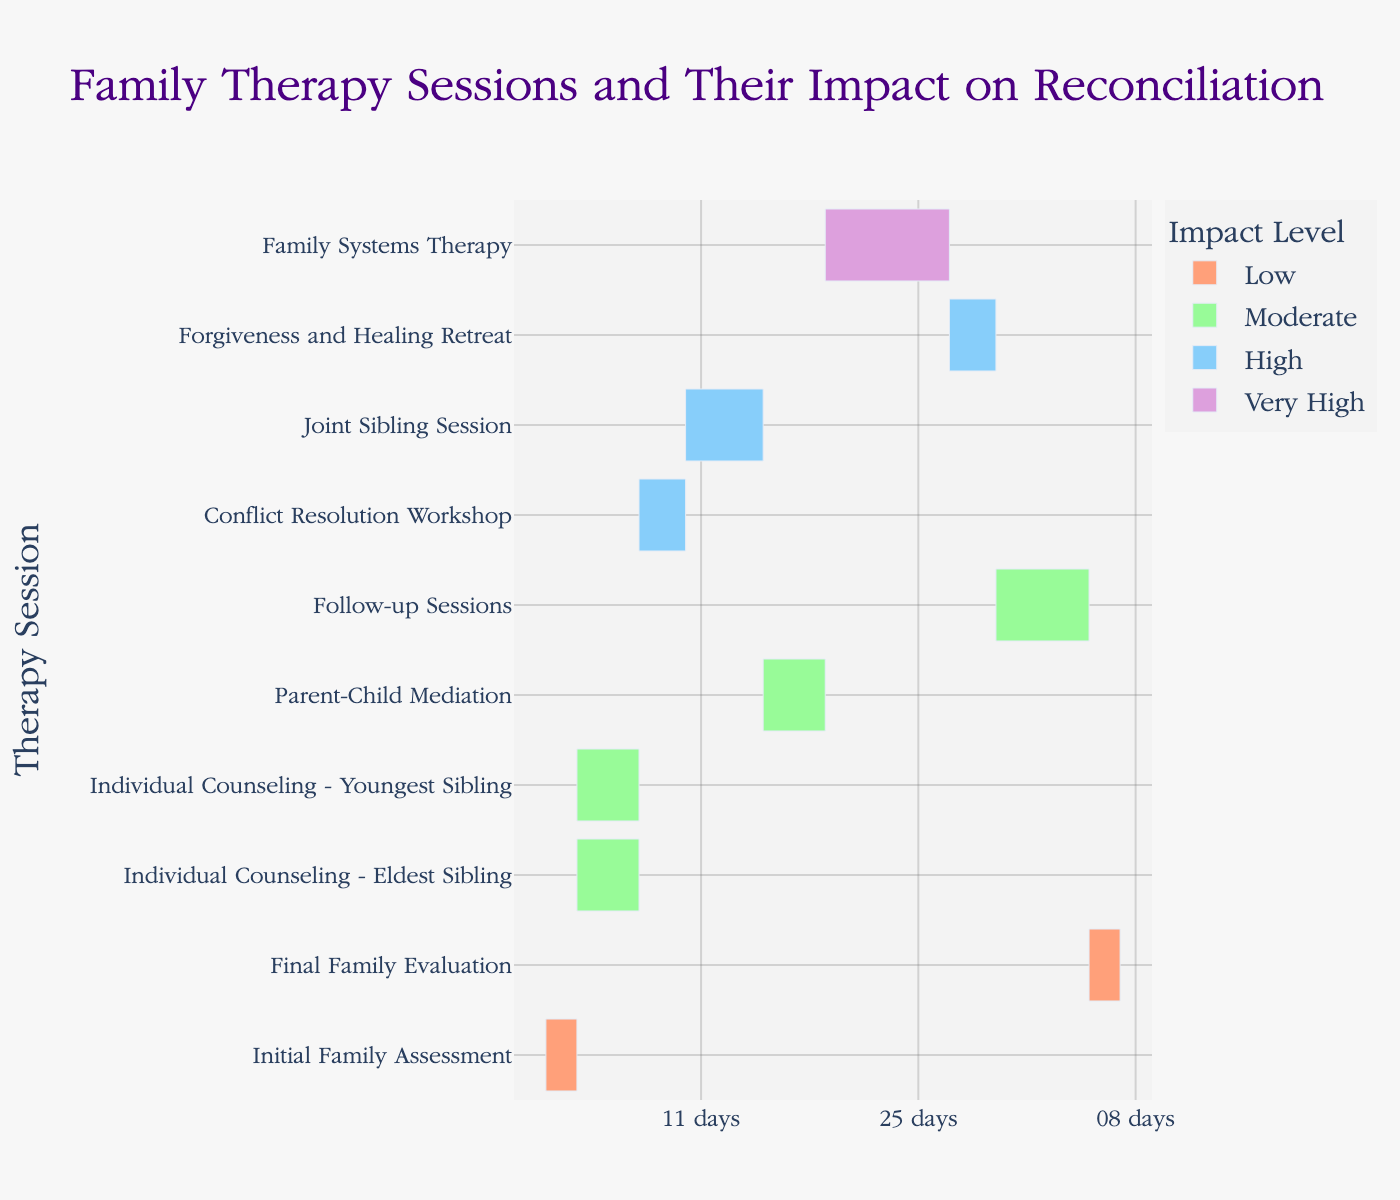What's the title of the figure? The title is usually found at the top of the chart, providing a quick understanding of what the chart is about. By observing the top-most text, we see that the title reads "Family Therapy Sessions and Their Impact on Reconciliation."
Answer: Family Therapy Sessions and Their Impact on Reconciliation How many therapy sessions are depicted in the chart? By counting the number of entries listed vertically (each row representing a therapy session), we total them to find there are 10 therapy sessions depicted.
Answer: 10 Which therapy session has the highest impact on reconciliation? Impact levels are color-coded. By identifying the darkest shade that represents "Very High," we see that "Family Systems Therapy" matches this color.
Answer: Family Systems Therapy How long did the Conflict Resolution Workshop last? The duration of each session is depicted by the length of the bar. By hovering over or consulting the hover data for "Conflict Resolution Workshop," we see it lasted for 3 days.
Answer: 3 days Which session had the longest duration? Examining the length of each bar, the "Family Systems Therapy" has the longest bar starting at day 18 and ending at day 26, totaling 8 days.
Answer: Family Systems Therapy How many sessions were considered to have a 'Moderate' impact? Color-coding indicates different levels of impact. Counting the bars with the "Moderate" color, we find there are 4 such sessions: "Individual Counseling - Eldest Sibling," "Individual Counseling - Youngest Sibling," "Parent-Child Mediation," and "Follow-up Sessions."
Answer: 4 Calculate the total duration of all the sessions combined. Sum up the durations provided for each session: 2 + 4 + 4 + 3 + 5 + 4 + 8 + 3 + 6 + 2 = 41 days.
Answer: 41 days Which sessions had their durations overlapping? Checking the start and end dates of each session: "Individual Counseling - Eldest Sibling" and "Individual Counseling - Youngest Sibling" both run from days 2 to 6, thus overlapping.
Answer: Individual Counseling - Eldest Sibling and Individual Counseling - Youngest Sibling What is the total duration of sessions that had a 'High' impact? Sum the durations of sessions with 'High' impact: "Conflict Resolution Workshop" (3 days), "Joint Sibling Session" (5 days), and "Forgiveness and Healing Retreat" (3 days). The total is 3 + 5 + 3 = 11 days.
Answer: 11 days How many days after the initial assessment did the Joint Sibling Session start? The Joint Sibling Session started on day 9 and the Initial Family Assessment started on day 0. Subtracting these gives 9 - 0 = 9 days.
Answer: 9 days 